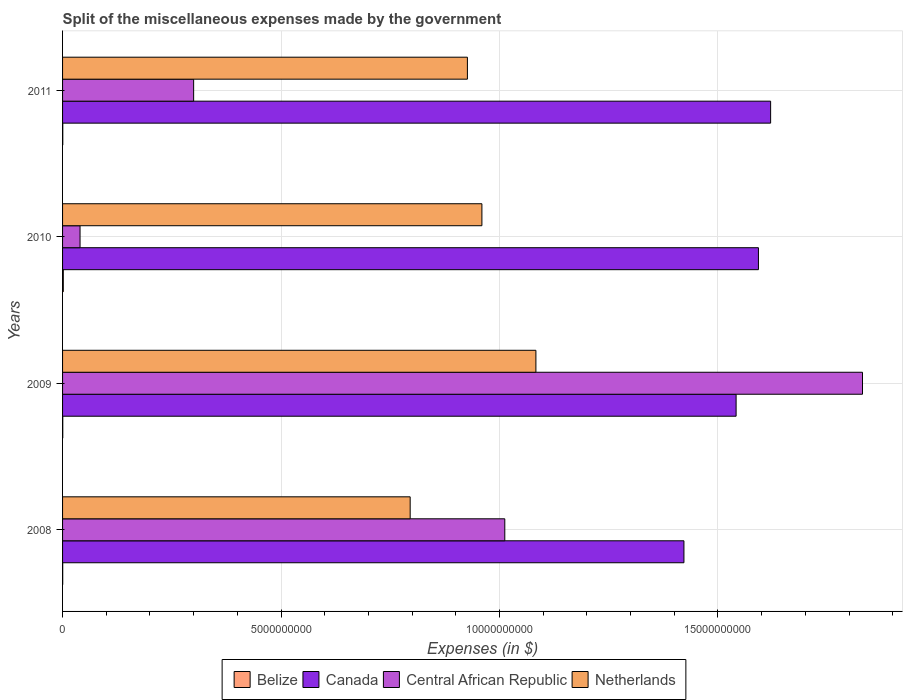How many groups of bars are there?
Keep it short and to the point. 4. Are the number of bars per tick equal to the number of legend labels?
Make the answer very short. Yes. How many bars are there on the 1st tick from the top?
Your answer should be very brief. 4. What is the label of the 4th group of bars from the top?
Provide a short and direct response. 2008. What is the miscellaneous expenses made by the government in Canada in 2010?
Offer a very short reply. 1.59e+1. Across all years, what is the maximum miscellaneous expenses made by the government in Canada?
Offer a very short reply. 1.62e+1. Across all years, what is the minimum miscellaneous expenses made by the government in Central African Republic?
Ensure brevity in your answer.  4.00e+08. What is the total miscellaneous expenses made by the government in Belize in the graph?
Provide a succinct answer. 2.90e+07. What is the difference between the miscellaneous expenses made by the government in Canada in 2008 and that in 2010?
Make the answer very short. -1.70e+09. What is the difference between the miscellaneous expenses made by the government in Netherlands in 2011 and the miscellaneous expenses made by the government in Belize in 2008?
Your response must be concise. 9.26e+09. What is the average miscellaneous expenses made by the government in Netherlands per year?
Your answer should be very brief. 9.41e+09. In the year 2008, what is the difference between the miscellaneous expenses made by the government in Belize and miscellaneous expenses made by the government in Netherlands?
Your response must be concise. -7.95e+09. What is the ratio of the miscellaneous expenses made by the government in Netherlands in 2009 to that in 2010?
Provide a short and direct response. 1.13. What is the difference between the highest and the second highest miscellaneous expenses made by the government in Central African Republic?
Ensure brevity in your answer.  8.19e+09. What is the difference between the highest and the lowest miscellaneous expenses made by the government in Central African Republic?
Offer a terse response. 1.79e+1. Is the sum of the miscellaneous expenses made by the government in Belize in 2008 and 2011 greater than the maximum miscellaneous expenses made by the government in Netherlands across all years?
Ensure brevity in your answer.  No. What does the 2nd bar from the top in 2008 represents?
Offer a very short reply. Central African Republic. What does the 3rd bar from the bottom in 2010 represents?
Offer a very short reply. Central African Republic. How many bars are there?
Offer a terse response. 16. Are all the bars in the graph horizontal?
Your response must be concise. Yes. How many years are there in the graph?
Your answer should be very brief. 4. Does the graph contain any zero values?
Keep it short and to the point. No. Does the graph contain grids?
Keep it short and to the point. Yes. Where does the legend appear in the graph?
Your answer should be very brief. Bottom center. How many legend labels are there?
Give a very brief answer. 4. What is the title of the graph?
Your response must be concise. Split of the miscellaneous expenses made by the government. Does "France" appear as one of the legend labels in the graph?
Provide a short and direct response. No. What is the label or title of the X-axis?
Provide a succinct answer. Expenses (in $). What is the label or title of the Y-axis?
Your response must be concise. Years. What is the Expenses (in $) of Belize in 2008?
Offer a very short reply. 3.21e+06. What is the Expenses (in $) of Canada in 2008?
Ensure brevity in your answer.  1.42e+1. What is the Expenses (in $) in Central African Republic in 2008?
Provide a succinct answer. 1.01e+1. What is the Expenses (in $) in Netherlands in 2008?
Give a very brief answer. 7.96e+09. What is the Expenses (in $) of Belize in 2009?
Ensure brevity in your answer.  4.39e+06. What is the Expenses (in $) of Canada in 2009?
Your answer should be compact. 1.54e+1. What is the Expenses (in $) of Central African Republic in 2009?
Provide a succinct answer. 1.83e+1. What is the Expenses (in $) in Netherlands in 2009?
Offer a very short reply. 1.08e+1. What is the Expenses (in $) of Belize in 2010?
Your response must be concise. 1.66e+07. What is the Expenses (in $) in Canada in 2010?
Provide a short and direct response. 1.59e+1. What is the Expenses (in $) in Central African Republic in 2010?
Your answer should be compact. 4.00e+08. What is the Expenses (in $) of Netherlands in 2010?
Offer a very short reply. 9.60e+09. What is the Expenses (in $) in Belize in 2011?
Provide a short and direct response. 4.85e+06. What is the Expenses (in $) in Canada in 2011?
Offer a very short reply. 1.62e+1. What is the Expenses (in $) of Central African Republic in 2011?
Offer a very short reply. 3.00e+09. What is the Expenses (in $) in Netherlands in 2011?
Your answer should be very brief. 9.27e+09. Across all years, what is the maximum Expenses (in $) of Belize?
Ensure brevity in your answer.  1.66e+07. Across all years, what is the maximum Expenses (in $) of Canada?
Ensure brevity in your answer.  1.62e+1. Across all years, what is the maximum Expenses (in $) in Central African Republic?
Your answer should be compact. 1.83e+1. Across all years, what is the maximum Expenses (in $) in Netherlands?
Keep it short and to the point. 1.08e+1. Across all years, what is the minimum Expenses (in $) in Belize?
Your answer should be very brief. 3.21e+06. Across all years, what is the minimum Expenses (in $) in Canada?
Make the answer very short. 1.42e+1. Across all years, what is the minimum Expenses (in $) in Central African Republic?
Offer a very short reply. 4.00e+08. Across all years, what is the minimum Expenses (in $) of Netherlands?
Give a very brief answer. 7.96e+09. What is the total Expenses (in $) in Belize in the graph?
Your response must be concise. 2.90e+07. What is the total Expenses (in $) of Canada in the graph?
Give a very brief answer. 6.18e+1. What is the total Expenses (in $) in Central African Republic in the graph?
Ensure brevity in your answer.  3.18e+1. What is the total Expenses (in $) in Netherlands in the graph?
Ensure brevity in your answer.  3.77e+1. What is the difference between the Expenses (in $) in Belize in 2008 and that in 2009?
Your answer should be very brief. -1.19e+06. What is the difference between the Expenses (in $) of Canada in 2008 and that in 2009?
Your answer should be compact. -1.19e+09. What is the difference between the Expenses (in $) of Central African Republic in 2008 and that in 2009?
Your answer should be very brief. -8.19e+09. What is the difference between the Expenses (in $) of Netherlands in 2008 and that in 2009?
Give a very brief answer. -2.88e+09. What is the difference between the Expenses (in $) in Belize in 2008 and that in 2010?
Your response must be concise. -1.33e+07. What is the difference between the Expenses (in $) of Canada in 2008 and that in 2010?
Provide a succinct answer. -1.70e+09. What is the difference between the Expenses (in $) in Central African Republic in 2008 and that in 2010?
Make the answer very short. 9.72e+09. What is the difference between the Expenses (in $) in Netherlands in 2008 and that in 2010?
Provide a short and direct response. -1.64e+09. What is the difference between the Expenses (in $) of Belize in 2008 and that in 2011?
Provide a succinct answer. -1.64e+06. What is the difference between the Expenses (in $) in Canada in 2008 and that in 2011?
Offer a very short reply. -1.98e+09. What is the difference between the Expenses (in $) of Central African Republic in 2008 and that in 2011?
Provide a succinct answer. 7.12e+09. What is the difference between the Expenses (in $) of Netherlands in 2008 and that in 2011?
Make the answer very short. -1.31e+09. What is the difference between the Expenses (in $) of Belize in 2009 and that in 2010?
Offer a very short reply. -1.22e+07. What is the difference between the Expenses (in $) in Canada in 2009 and that in 2010?
Keep it short and to the point. -5.11e+08. What is the difference between the Expenses (in $) in Central African Republic in 2009 and that in 2010?
Offer a very short reply. 1.79e+1. What is the difference between the Expenses (in $) in Netherlands in 2009 and that in 2010?
Give a very brief answer. 1.24e+09. What is the difference between the Expenses (in $) of Belize in 2009 and that in 2011?
Give a very brief answer. -4.52e+05. What is the difference between the Expenses (in $) in Canada in 2009 and that in 2011?
Your answer should be very brief. -7.90e+08. What is the difference between the Expenses (in $) of Central African Republic in 2009 and that in 2011?
Give a very brief answer. 1.53e+1. What is the difference between the Expenses (in $) in Netherlands in 2009 and that in 2011?
Offer a terse response. 1.57e+09. What is the difference between the Expenses (in $) of Belize in 2010 and that in 2011?
Your response must be concise. 1.17e+07. What is the difference between the Expenses (in $) of Canada in 2010 and that in 2011?
Offer a terse response. -2.79e+08. What is the difference between the Expenses (in $) in Central African Republic in 2010 and that in 2011?
Provide a succinct answer. -2.60e+09. What is the difference between the Expenses (in $) of Netherlands in 2010 and that in 2011?
Your answer should be compact. 3.32e+08. What is the difference between the Expenses (in $) of Belize in 2008 and the Expenses (in $) of Canada in 2009?
Provide a short and direct response. -1.54e+1. What is the difference between the Expenses (in $) in Belize in 2008 and the Expenses (in $) in Central African Republic in 2009?
Give a very brief answer. -1.83e+1. What is the difference between the Expenses (in $) in Belize in 2008 and the Expenses (in $) in Netherlands in 2009?
Your response must be concise. -1.08e+1. What is the difference between the Expenses (in $) of Canada in 2008 and the Expenses (in $) of Central African Republic in 2009?
Offer a very short reply. -4.09e+09. What is the difference between the Expenses (in $) in Canada in 2008 and the Expenses (in $) in Netherlands in 2009?
Your response must be concise. 3.39e+09. What is the difference between the Expenses (in $) in Central African Republic in 2008 and the Expenses (in $) in Netherlands in 2009?
Offer a terse response. -7.12e+08. What is the difference between the Expenses (in $) in Belize in 2008 and the Expenses (in $) in Canada in 2010?
Make the answer very short. -1.59e+1. What is the difference between the Expenses (in $) of Belize in 2008 and the Expenses (in $) of Central African Republic in 2010?
Provide a short and direct response. -3.97e+08. What is the difference between the Expenses (in $) of Belize in 2008 and the Expenses (in $) of Netherlands in 2010?
Keep it short and to the point. -9.59e+09. What is the difference between the Expenses (in $) in Canada in 2008 and the Expenses (in $) in Central African Republic in 2010?
Provide a short and direct response. 1.38e+1. What is the difference between the Expenses (in $) in Canada in 2008 and the Expenses (in $) in Netherlands in 2010?
Keep it short and to the point. 4.62e+09. What is the difference between the Expenses (in $) of Central African Republic in 2008 and the Expenses (in $) of Netherlands in 2010?
Offer a very short reply. 5.24e+08. What is the difference between the Expenses (in $) of Belize in 2008 and the Expenses (in $) of Canada in 2011?
Offer a terse response. -1.62e+1. What is the difference between the Expenses (in $) of Belize in 2008 and the Expenses (in $) of Central African Republic in 2011?
Your answer should be compact. -3.00e+09. What is the difference between the Expenses (in $) of Belize in 2008 and the Expenses (in $) of Netherlands in 2011?
Provide a short and direct response. -9.26e+09. What is the difference between the Expenses (in $) of Canada in 2008 and the Expenses (in $) of Central African Republic in 2011?
Give a very brief answer. 1.12e+1. What is the difference between the Expenses (in $) in Canada in 2008 and the Expenses (in $) in Netherlands in 2011?
Your answer should be compact. 4.96e+09. What is the difference between the Expenses (in $) of Central African Republic in 2008 and the Expenses (in $) of Netherlands in 2011?
Provide a succinct answer. 8.56e+08. What is the difference between the Expenses (in $) in Belize in 2009 and the Expenses (in $) in Canada in 2010?
Your answer should be compact. -1.59e+1. What is the difference between the Expenses (in $) of Belize in 2009 and the Expenses (in $) of Central African Republic in 2010?
Ensure brevity in your answer.  -3.96e+08. What is the difference between the Expenses (in $) in Belize in 2009 and the Expenses (in $) in Netherlands in 2010?
Offer a very short reply. -9.59e+09. What is the difference between the Expenses (in $) in Canada in 2009 and the Expenses (in $) in Central African Republic in 2010?
Give a very brief answer. 1.50e+1. What is the difference between the Expenses (in $) of Canada in 2009 and the Expenses (in $) of Netherlands in 2010?
Your response must be concise. 5.82e+09. What is the difference between the Expenses (in $) in Central African Republic in 2009 and the Expenses (in $) in Netherlands in 2010?
Your answer should be very brief. 8.71e+09. What is the difference between the Expenses (in $) in Belize in 2009 and the Expenses (in $) in Canada in 2011?
Your answer should be very brief. -1.62e+1. What is the difference between the Expenses (in $) of Belize in 2009 and the Expenses (in $) of Central African Republic in 2011?
Ensure brevity in your answer.  -3.00e+09. What is the difference between the Expenses (in $) of Belize in 2009 and the Expenses (in $) of Netherlands in 2011?
Make the answer very short. -9.26e+09. What is the difference between the Expenses (in $) of Canada in 2009 and the Expenses (in $) of Central African Republic in 2011?
Keep it short and to the point. 1.24e+1. What is the difference between the Expenses (in $) in Canada in 2009 and the Expenses (in $) in Netherlands in 2011?
Provide a short and direct response. 6.15e+09. What is the difference between the Expenses (in $) of Central African Republic in 2009 and the Expenses (in $) of Netherlands in 2011?
Provide a succinct answer. 9.04e+09. What is the difference between the Expenses (in $) in Belize in 2010 and the Expenses (in $) in Canada in 2011?
Your answer should be very brief. -1.62e+1. What is the difference between the Expenses (in $) in Belize in 2010 and the Expenses (in $) in Central African Republic in 2011?
Ensure brevity in your answer.  -2.98e+09. What is the difference between the Expenses (in $) of Belize in 2010 and the Expenses (in $) of Netherlands in 2011?
Offer a terse response. -9.25e+09. What is the difference between the Expenses (in $) in Canada in 2010 and the Expenses (in $) in Central African Republic in 2011?
Your response must be concise. 1.29e+1. What is the difference between the Expenses (in $) of Canada in 2010 and the Expenses (in $) of Netherlands in 2011?
Your answer should be very brief. 6.66e+09. What is the difference between the Expenses (in $) in Central African Republic in 2010 and the Expenses (in $) in Netherlands in 2011?
Provide a succinct answer. -8.87e+09. What is the average Expenses (in $) in Belize per year?
Ensure brevity in your answer.  7.25e+06. What is the average Expenses (in $) in Canada per year?
Give a very brief answer. 1.54e+1. What is the average Expenses (in $) of Central African Republic per year?
Provide a succinct answer. 7.96e+09. What is the average Expenses (in $) of Netherlands per year?
Make the answer very short. 9.41e+09. In the year 2008, what is the difference between the Expenses (in $) in Belize and Expenses (in $) in Canada?
Your response must be concise. -1.42e+1. In the year 2008, what is the difference between the Expenses (in $) of Belize and Expenses (in $) of Central African Republic?
Your response must be concise. -1.01e+1. In the year 2008, what is the difference between the Expenses (in $) in Belize and Expenses (in $) in Netherlands?
Offer a very short reply. -7.95e+09. In the year 2008, what is the difference between the Expenses (in $) in Canada and Expenses (in $) in Central African Republic?
Your response must be concise. 4.10e+09. In the year 2008, what is the difference between the Expenses (in $) of Canada and Expenses (in $) of Netherlands?
Offer a very short reply. 6.27e+09. In the year 2008, what is the difference between the Expenses (in $) in Central African Republic and Expenses (in $) in Netherlands?
Offer a terse response. 2.17e+09. In the year 2009, what is the difference between the Expenses (in $) in Belize and Expenses (in $) in Canada?
Offer a very short reply. -1.54e+1. In the year 2009, what is the difference between the Expenses (in $) of Belize and Expenses (in $) of Central African Republic?
Provide a short and direct response. -1.83e+1. In the year 2009, what is the difference between the Expenses (in $) of Belize and Expenses (in $) of Netherlands?
Provide a short and direct response. -1.08e+1. In the year 2009, what is the difference between the Expenses (in $) in Canada and Expenses (in $) in Central African Republic?
Provide a short and direct response. -2.89e+09. In the year 2009, what is the difference between the Expenses (in $) of Canada and Expenses (in $) of Netherlands?
Make the answer very short. 4.58e+09. In the year 2009, what is the difference between the Expenses (in $) in Central African Republic and Expenses (in $) in Netherlands?
Keep it short and to the point. 7.47e+09. In the year 2010, what is the difference between the Expenses (in $) in Belize and Expenses (in $) in Canada?
Offer a very short reply. -1.59e+1. In the year 2010, what is the difference between the Expenses (in $) in Belize and Expenses (in $) in Central African Republic?
Give a very brief answer. -3.83e+08. In the year 2010, what is the difference between the Expenses (in $) in Belize and Expenses (in $) in Netherlands?
Your answer should be compact. -9.58e+09. In the year 2010, what is the difference between the Expenses (in $) in Canada and Expenses (in $) in Central African Republic?
Offer a terse response. 1.55e+1. In the year 2010, what is the difference between the Expenses (in $) of Canada and Expenses (in $) of Netherlands?
Ensure brevity in your answer.  6.33e+09. In the year 2010, what is the difference between the Expenses (in $) in Central African Republic and Expenses (in $) in Netherlands?
Provide a succinct answer. -9.20e+09. In the year 2011, what is the difference between the Expenses (in $) of Belize and Expenses (in $) of Canada?
Keep it short and to the point. -1.62e+1. In the year 2011, what is the difference between the Expenses (in $) in Belize and Expenses (in $) in Central African Republic?
Your answer should be very brief. -3.00e+09. In the year 2011, what is the difference between the Expenses (in $) of Belize and Expenses (in $) of Netherlands?
Provide a succinct answer. -9.26e+09. In the year 2011, what is the difference between the Expenses (in $) in Canada and Expenses (in $) in Central African Republic?
Your response must be concise. 1.32e+1. In the year 2011, what is the difference between the Expenses (in $) of Canada and Expenses (in $) of Netherlands?
Provide a succinct answer. 6.94e+09. In the year 2011, what is the difference between the Expenses (in $) of Central African Republic and Expenses (in $) of Netherlands?
Provide a succinct answer. -6.27e+09. What is the ratio of the Expenses (in $) in Belize in 2008 to that in 2009?
Provide a short and direct response. 0.73. What is the ratio of the Expenses (in $) in Canada in 2008 to that in 2009?
Give a very brief answer. 0.92. What is the ratio of the Expenses (in $) of Central African Republic in 2008 to that in 2009?
Make the answer very short. 0.55. What is the ratio of the Expenses (in $) of Netherlands in 2008 to that in 2009?
Make the answer very short. 0.73. What is the ratio of the Expenses (in $) in Belize in 2008 to that in 2010?
Offer a terse response. 0.19. What is the ratio of the Expenses (in $) in Canada in 2008 to that in 2010?
Make the answer very short. 0.89. What is the ratio of the Expenses (in $) in Central African Republic in 2008 to that in 2010?
Ensure brevity in your answer.  25.3. What is the ratio of the Expenses (in $) in Netherlands in 2008 to that in 2010?
Your answer should be very brief. 0.83. What is the ratio of the Expenses (in $) in Belize in 2008 to that in 2011?
Provide a short and direct response. 0.66. What is the ratio of the Expenses (in $) of Canada in 2008 to that in 2011?
Ensure brevity in your answer.  0.88. What is the ratio of the Expenses (in $) of Central African Republic in 2008 to that in 2011?
Your answer should be very brief. 3.37. What is the ratio of the Expenses (in $) of Netherlands in 2008 to that in 2011?
Provide a short and direct response. 0.86. What is the ratio of the Expenses (in $) in Belize in 2009 to that in 2010?
Give a very brief answer. 0.27. What is the ratio of the Expenses (in $) in Canada in 2009 to that in 2010?
Offer a terse response. 0.97. What is the ratio of the Expenses (in $) in Central African Republic in 2009 to that in 2010?
Your answer should be compact. 45.77. What is the ratio of the Expenses (in $) in Netherlands in 2009 to that in 2010?
Offer a terse response. 1.13. What is the ratio of the Expenses (in $) of Belize in 2009 to that in 2011?
Your answer should be compact. 0.91. What is the ratio of the Expenses (in $) in Canada in 2009 to that in 2011?
Your answer should be compact. 0.95. What is the ratio of the Expenses (in $) of Central African Republic in 2009 to that in 2011?
Provide a succinct answer. 6.1. What is the ratio of the Expenses (in $) of Netherlands in 2009 to that in 2011?
Make the answer very short. 1.17. What is the ratio of the Expenses (in $) of Belize in 2010 to that in 2011?
Give a very brief answer. 3.42. What is the ratio of the Expenses (in $) of Canada in 2010 to that in 2011?
Provide a succinct answer. 0.98. What is the ratio of the Expenses (in $) of Central African Republic in 2010 to that in 2011?
Offer a very short reply. 0.13. What is the ratio of the Expenses (in $) of Netherlands in 2010 to that in 2011?
Your answer should be very brief. 1.04. What is the difference between the highest and the second highest Expenses (in $) of Belize?
Ensure brevity in your answer.  1.17e+07. What is the difference between the highest and the second highest Expenses (in $) of Canada?
Your response must be concise. 2.79e+08. What is the difference between the highest and the second highest Expenses (in $) of Central African Republic?
Give a very brief answer. 8.19e+09. What is the difference between the highest and the second highest Expenses (in $) of Netherlands?
Provide a succinct answer. 1.24e+09. What is the difference between the highest and the lowest Expenses (in $) in Belize?
Your answer should be compact. 1.33e+07. What is the difference between the highest and the lowest Expenses (in $) in Canada?
Your response must be concise. 1.98e+09. What is the difference between the highest and the lowest Expenses (in $) of Central African Republic?
Your answer should be very brief. 1.79e+1. What is the difference between the highest and the lowest Expenses (in $) of Netherlands?
Your answer should be compact. 2.88e+09. 